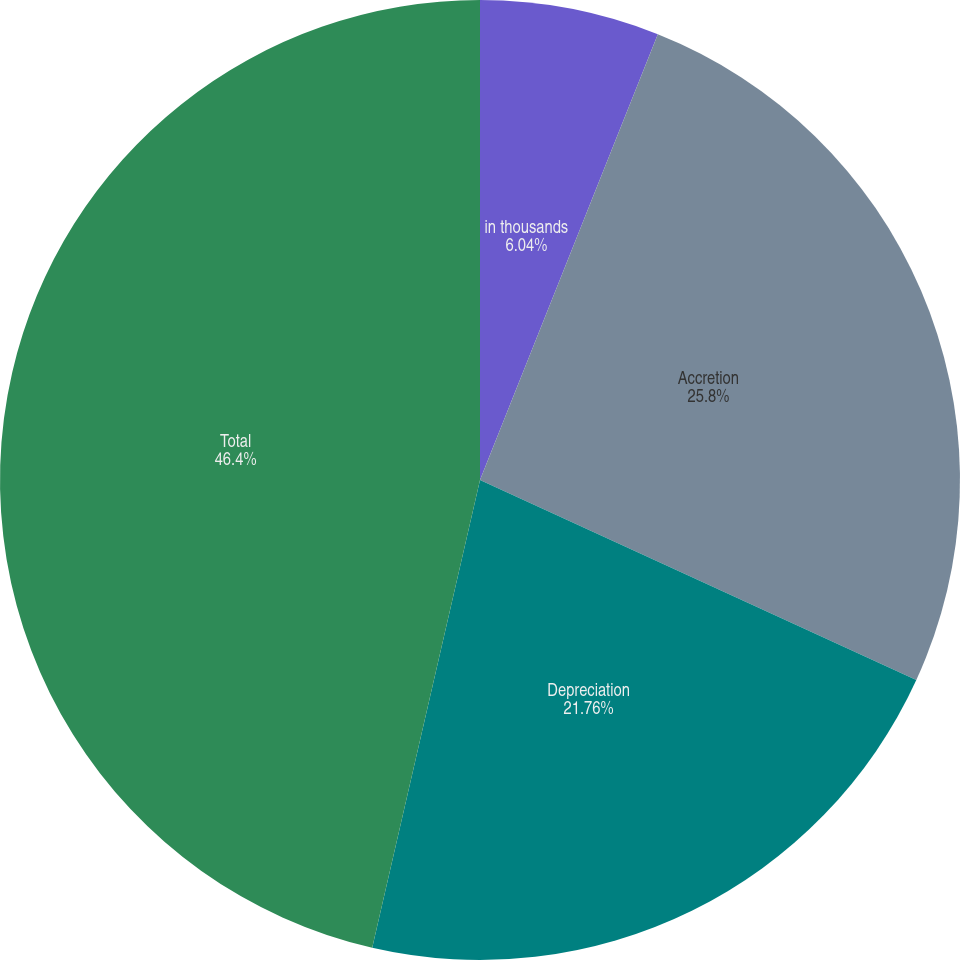Convert chart. <chart><loc_0><loc_0><loc_500><loc_500><pie_chart><fcel>in thousands<fcel>Accretion<fcel>Depreciation<fcel>Total<nl><fcel>6.04%<fcel>25.8%<fcel>21.76%<fcel>46.39%<nl></chart> 